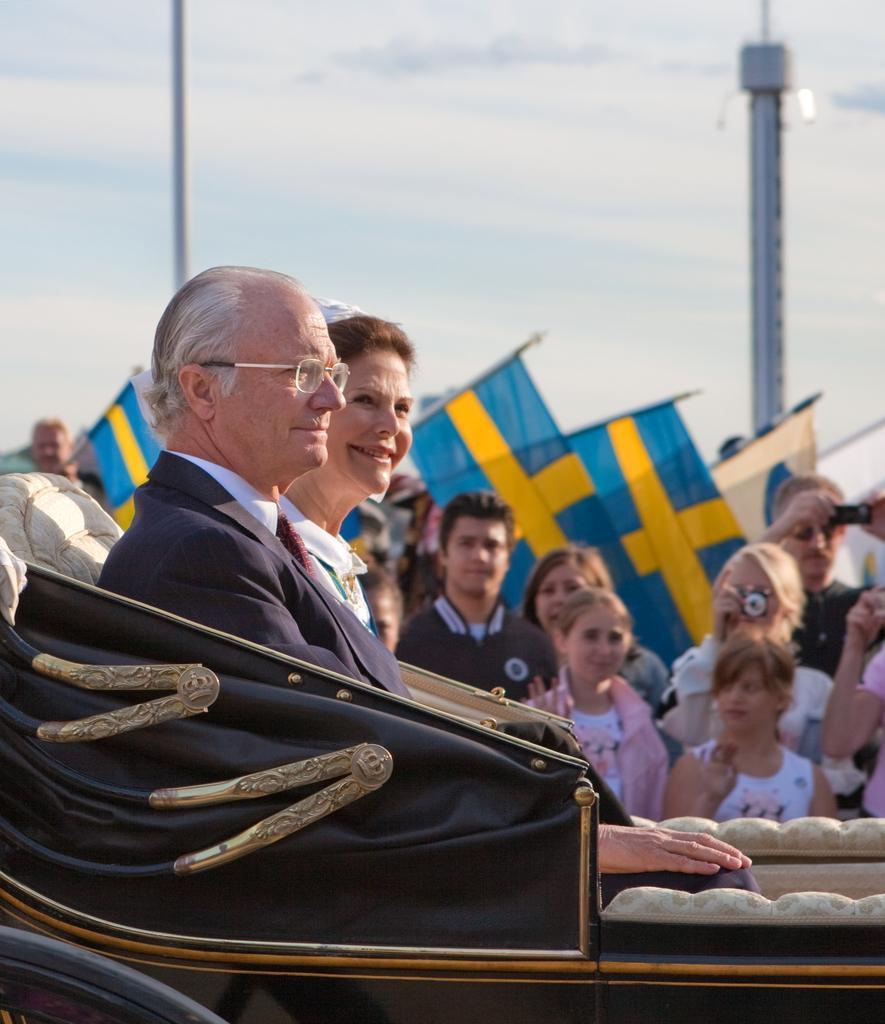In one or two sentences, can you explain what this image depicts? This image is clicked outside. There are two persons in the middle. One is man, another one is a woman. There are some other persons in the middle standing. There are some persons, who are clicking the pictures. 